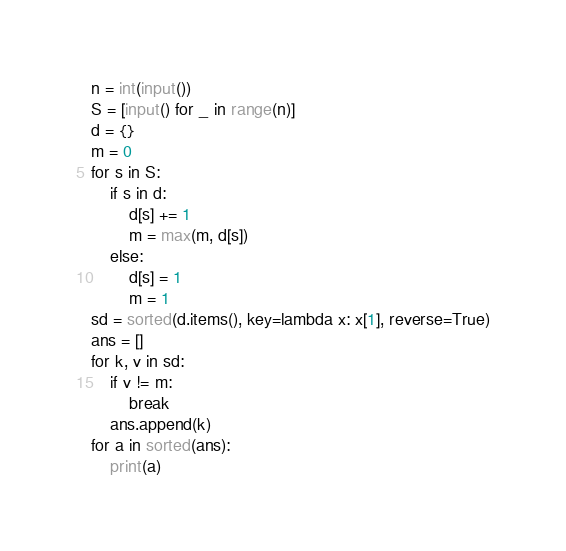Convert code to text. <code><loc_0><loc_0><loc_500><loc_500><_Python_>n = int(input())
S = [input() for _ in range(n)]
d = {}
m = 0
for s in S:
    if s in d:
        d[s] += 1
        m = max(m, d[s])
    else:
        d[s] = 1
        m = 1
sd = sorted(d.items(), key=lambda x: x[1], reverse=True)
ans = []
for k, v in sd:
    if v != m:
        break
    ans.append(k)
for a in sorted(ans):
    print(a)
</code> 